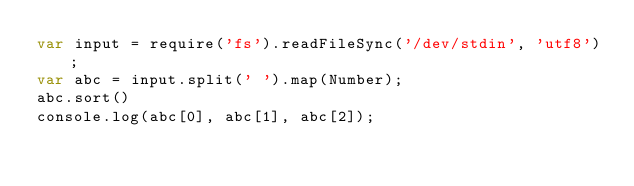Convert code to text. <code><loc_0><loc_0><loc_500><loc_500><_JavaScript_>var input = require('fs').readFileSync('/dev/stdin', 'utf8');
var abc = input.split(' ').map(Number);
abc.sort()
console.log(abc[0], abc[1], abc[2]);</code> 